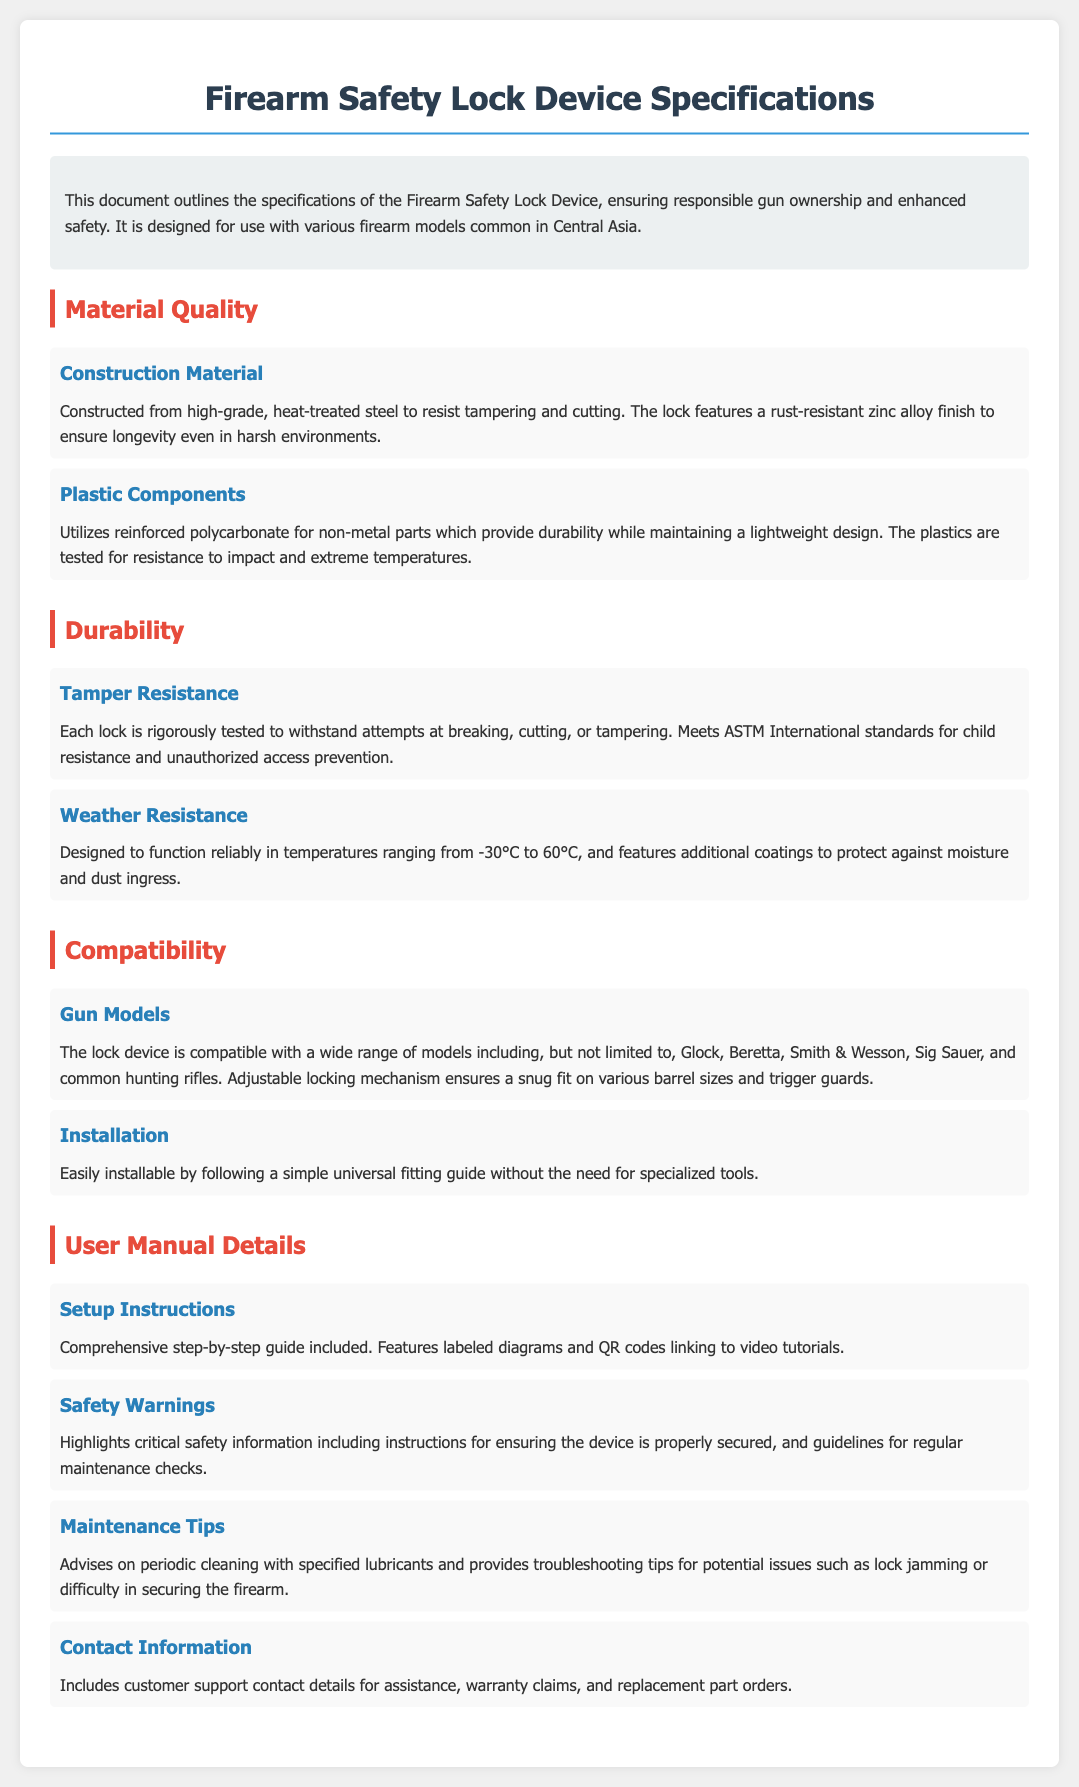what material is used for construction? The document specifies that the construction material is high-grade, heat-treated steel.
Answer: high-grade, heat-treated steel what is the temperature range for weather resistance? The device is designed to function reliably in temperatures ranging from -30°C to 60°C.
Answer: -30°C to 60°C which gun models are mentioned as compatible? The lock device is compatible with Glock, Beretta, Smith & Wesson, Sig Sauer, and common hunting rifles.
Answer: Glock, Beretta, Smith & Wesson, Sig Sauer, common hunting rifles what additional features are included in the user manual? The user manual includes labeled diagrams and QR codes linking to video tutorials.
Answer: labeled diagrams and QR codes how is the installation described? The installation is described as easily installable by following a simple universal fitting guide.
Answer: easily installable by following a simple universal fitting guide what type of plastic is used for non-metal parts? The document states that reinforced polycarbonate is used for non-metal parts.
Answer: reinforced polycarbonate what is noted about tamper resistance? Each lock is rigorously tested to withstand attempts at breaking, cutting, or tampering.
Answer: rigorously tested to withstand attempts at breaking, cutting, or tampering what contact information is included in the manual? The contact information includes customer support contact details for assistance and warranty claims.
Answer: customer support contact details for assistance and warranty claims 